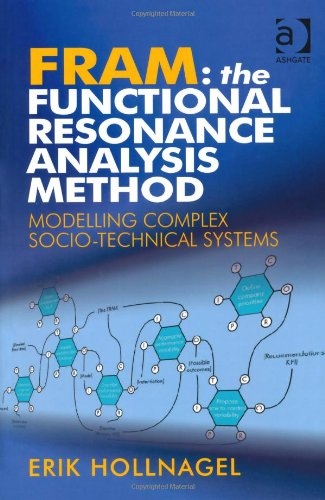What type of book is this? This is a 'Computers & Technology' book, specifically focusing on advanced methodologies for modeling and analyzing complex systems that involve both human and technological elements. 